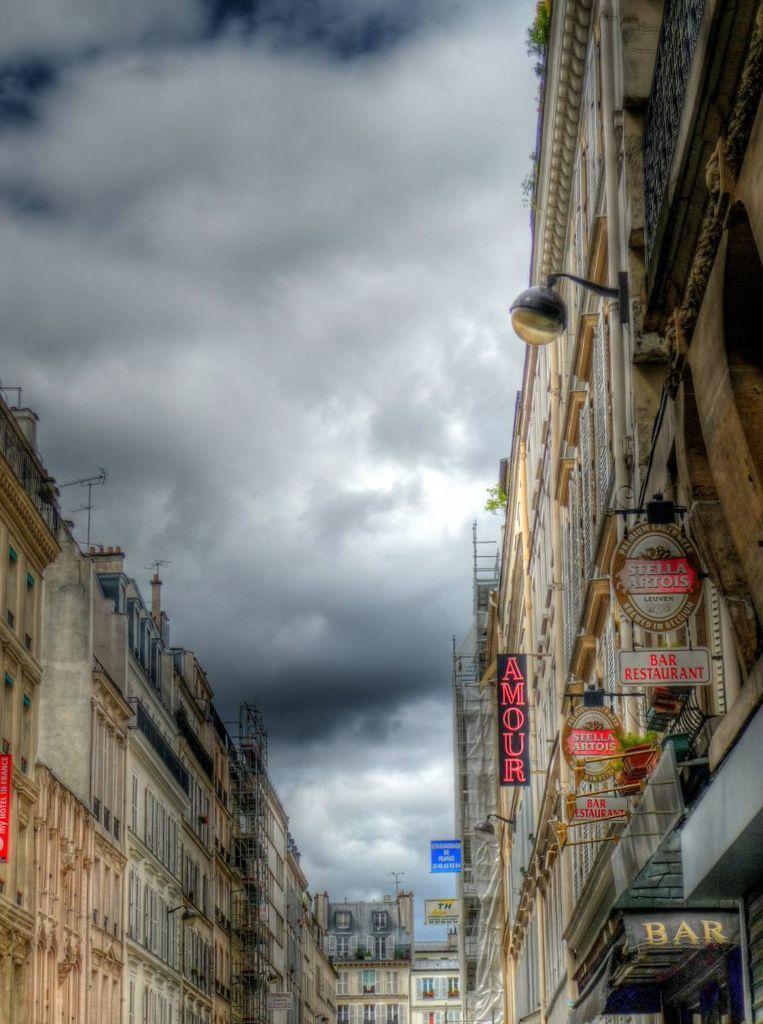Can you describe this image briefly? In this image we can see there are buildings with boards and text attached to the wall and there is a light attached to the building. And at the top we can see the sky. 